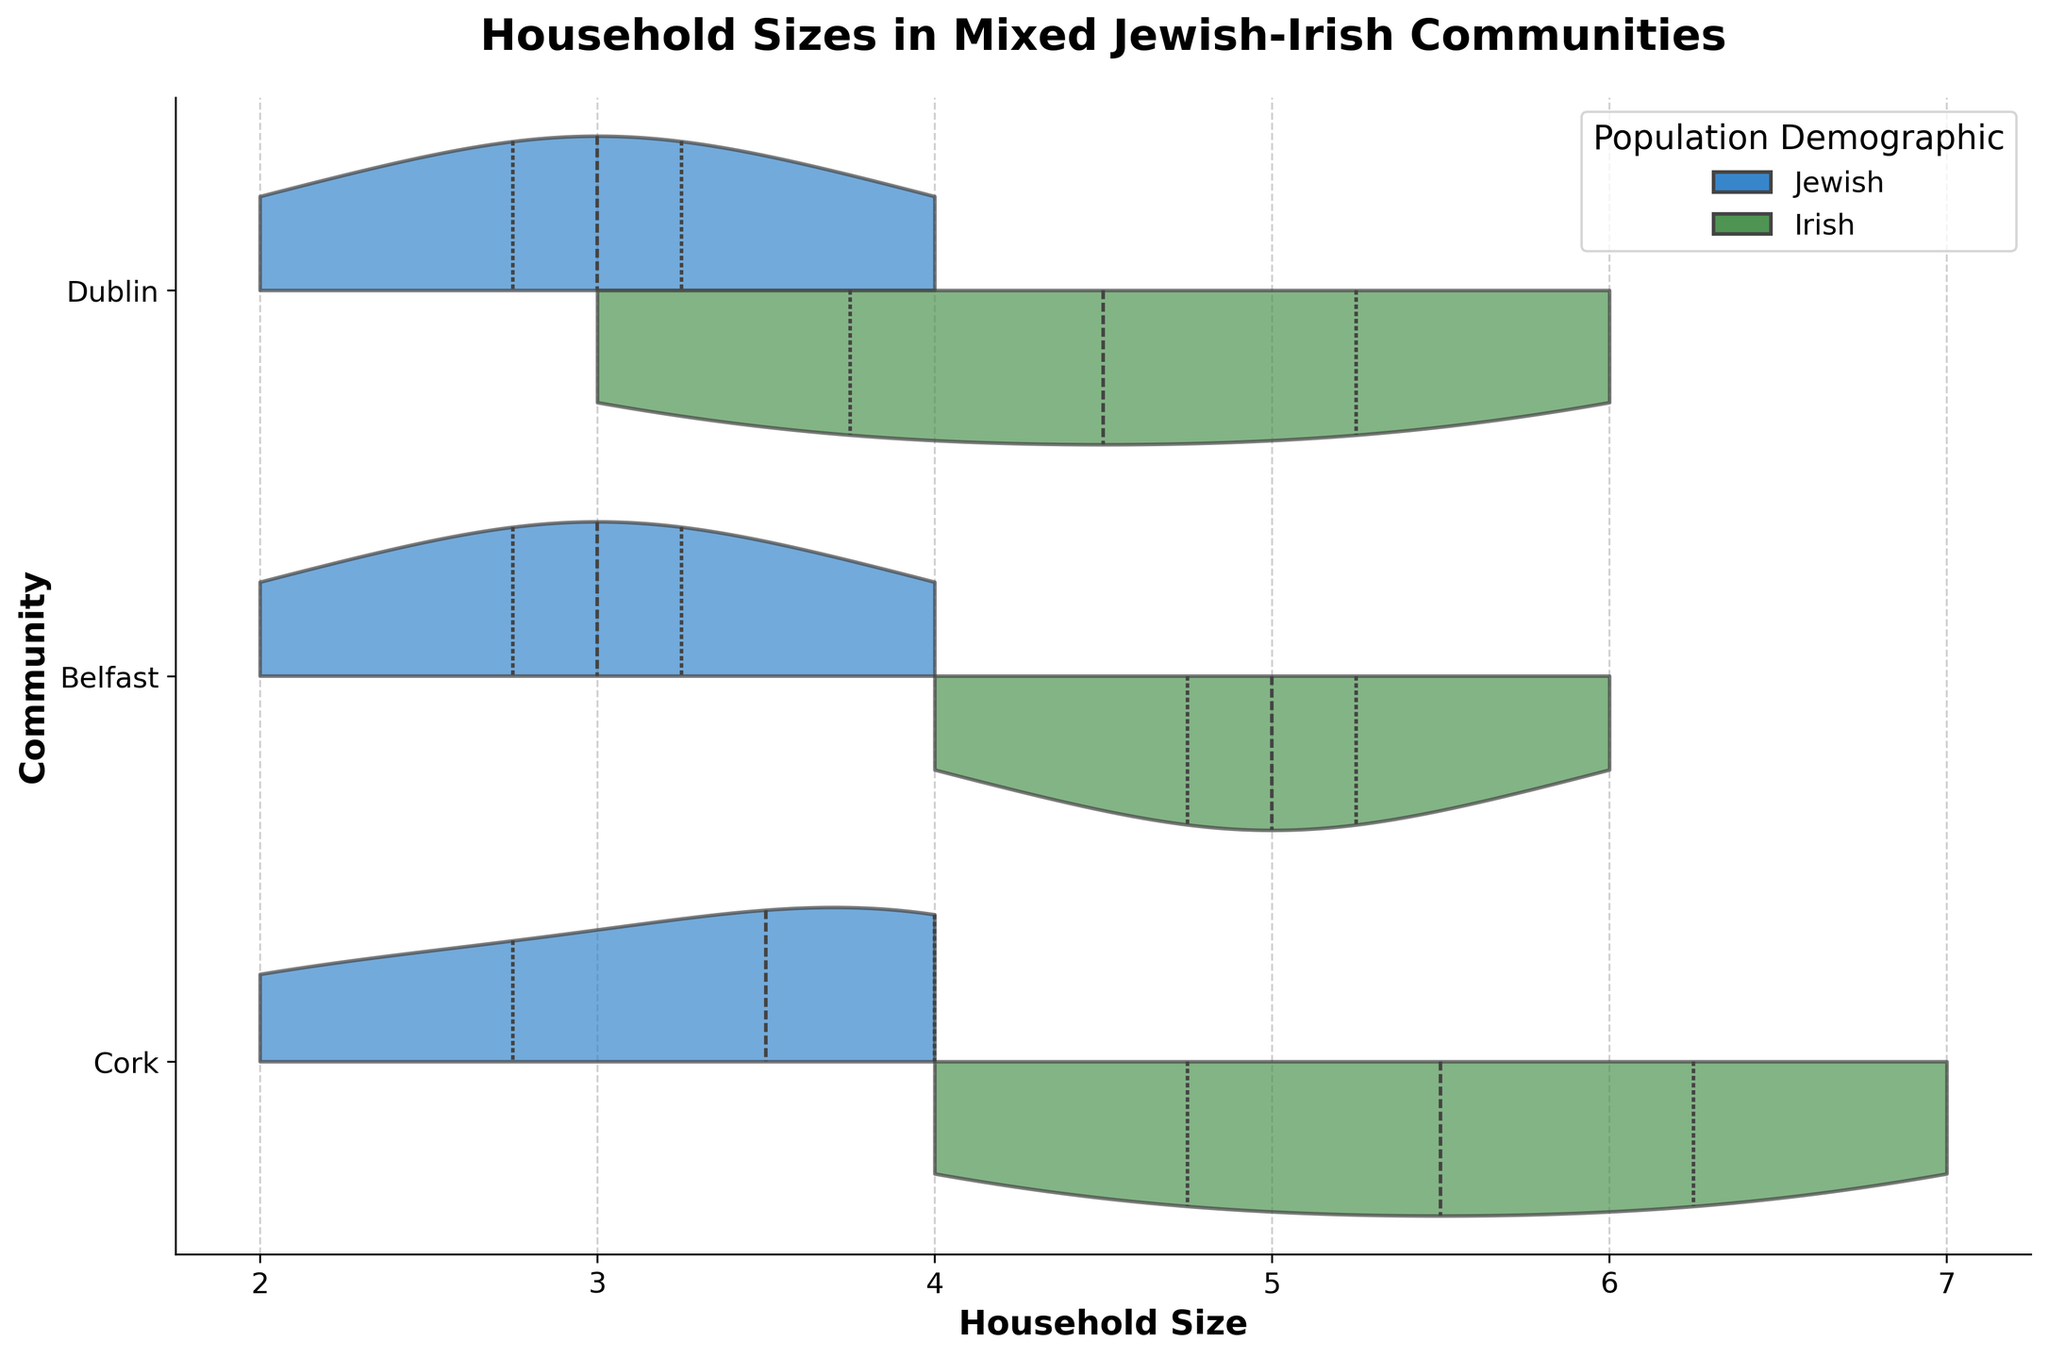What's the title of the plot? The title of the plot is usually found at the top of the figure. Here, it states "Household Sizes in Mixed Jewish-Irish Communities".
Answer: Household Sizes in Mixed Jewish-Irish Communities What are the communities represented in the plot? Each community is shown on the y-axis of the plot. The communities represented are Dublin, Belfast, and Cork.
Answer: Dublin, Belfast, Cork Which population demographic has a higher median household size in Dublin in 2010? The median can be determined by the thick line in the center of the violins. For Dublin in 2010, the Irish demographic shows a higher median household size compared to the Jewish demographic.
Answer: Irish How does the household size distribution of the Jewish population change over the years in Cork? Observe the shape and width of the blue violin plots for the Jewish population in Cork across different years. The distribution shows larger household sizes in 1990 and 2010 compared to 2000 and 2020.
Answer: It decreases, then increases, then decreases What is the smallest household size observed in Belfast for the Jewish population in 2020? Look at the leftmost extent of the blue violin plot for the Jewish population in Belfast in 2020. The smallest value corresponds to the minimum household size.
Answer: 3 Which community shows the largest difference in median household size between the Jewish and Irish populations in any single year? Compare the thick lines (medians) within each community and year combination. The largest gap is between Cork's Jewish and Irish populations in 2000.
Answer: Cork How does the household size for the Irish demographic in Dublin change from 1990 to 2020? Track the position of the thick line within the green violin plots for the Irish demographic in Dublin through the years. The sizes decrease from 1990 to 2010 and increase in 2020.
Answer: Decrease, then increase Is there any overlap in household size between Jewish and Irish populations in Belfast in 2010? Examine the violin plots for Belfast in 2010. If the two colored sections overlap horizontally within the same region, there is overlap of household sizes.
Answer: Yes Which demographic appears to have a more consistent household size across all communities and years? Look at the spread and variance within the violin plots. The Jewish population, indicated by blue violins, seems to have a more consistent household size distribution.
Answer: Jewish In which year did Cork have the smallest household size for both populations combined? Observe both the blue and green violins for Cork across all years. The smallest combined household size appears in 2020.
Answer: 2020 